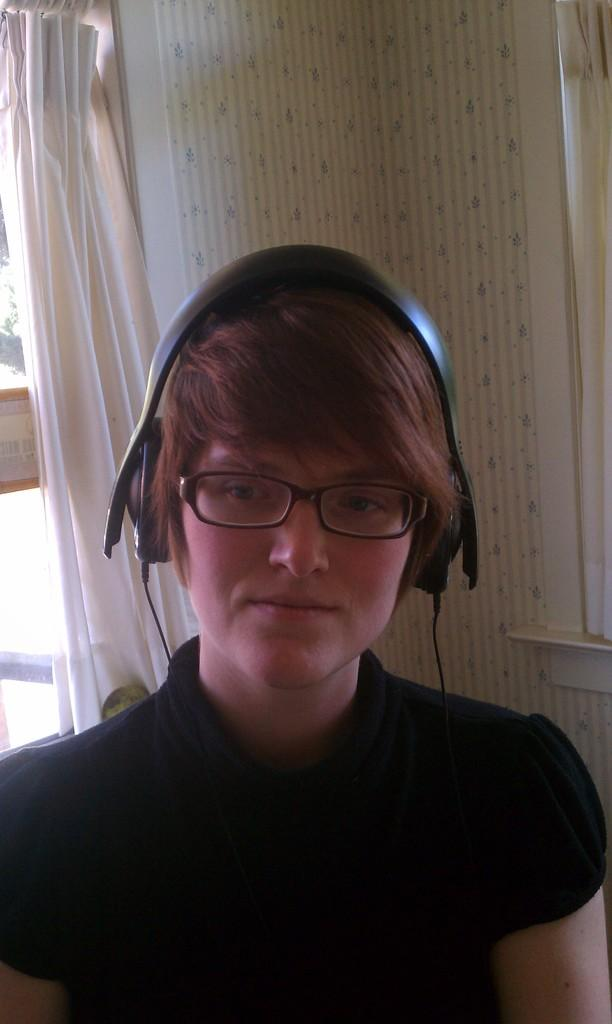What can be seen in the image that provides a view of the outside? There is a window in the image. Is there any window treatment visible in the image? Yes, there is a curtain in the image. Who is present in the image? There is a lady in the image. What is the lady doing in the image? The lady is listening to music. Where is the playground located in the image? There is no playground present in the image. What type of jewel is the lady wearing in the image? There is no mention of any jewelry in the image, so it cannot be determined if the lady is wearing a jewel. 